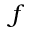Convert formula to latex. <formula><loc_0><loc_0><loc_500><loc_500>f</formula> 